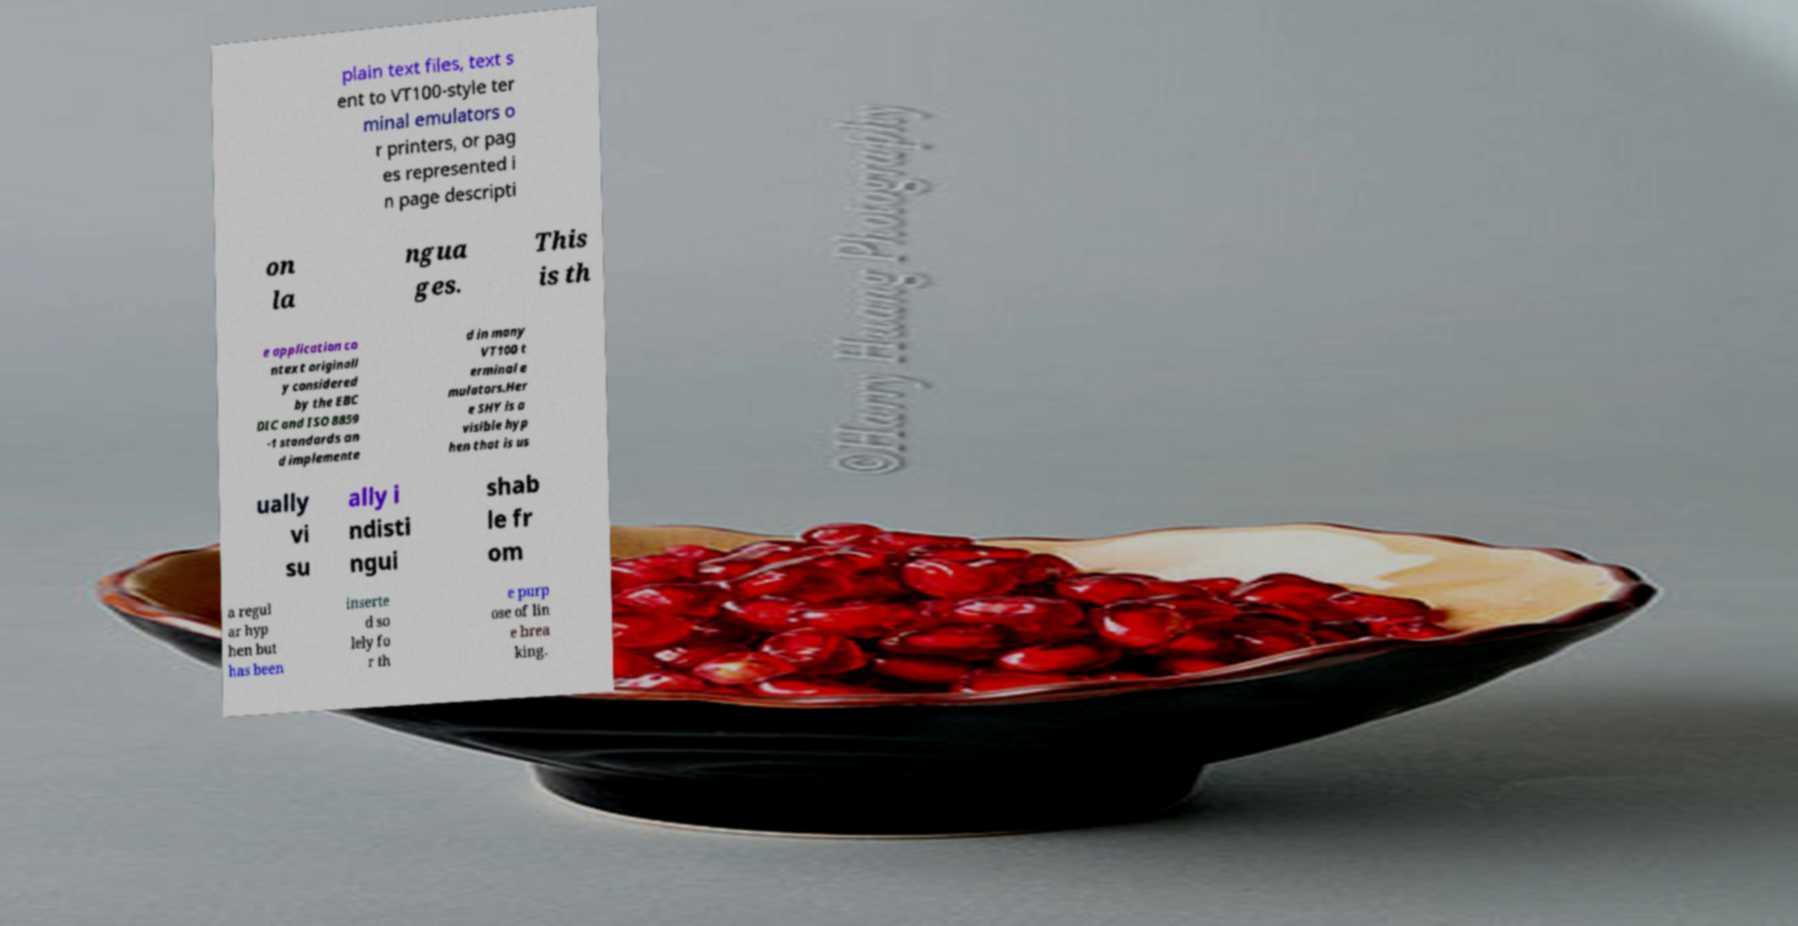Could you assist in decoding the text presented in this image and type it out clearly? plain text files, text s ent to VT100-style ter minal emulators o r printers, or pag es represented i n page descripti on la ngua ges. This is th e application co ntext originall y considered by the EBC DIC and ISO 8859 -1 standards an d implemente d in many VT100 t erminal e mulators.Her e SHY is a visible hyp hen that is us ually vi su ally i ndisti ngui shab le fr om a regul ar hyp hen but has been inserte d so lely fo r th e purp ose of lin e brea king. 